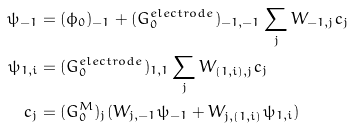<formula> <loc_0><loc_0><loc_500><loc_500>\psi _ { - 1 } & = ( \phi _ { 0 } ) _ { - 1 } + ( G _ { 0 } ^ { e l e c t r o d e } ) _ { - 1 , - 1 } \sum _ { j } W _ { - 1 , j } c _ { j } \\ \psi _ { 1 , i } & = ( G _ { 0 } ^ { e l e c t r o d e } ) _ { 1 , 1 } \sum _ { j } W _ { ( 1 , i ) , j } c _ { j } \\ c _ { j } & = ( G _ { 0 } ^ { M } ) _ { j } ( W _ { j , - 1 } \psi _ { - 1 } + W _ { j , ( 1 , i ) } \psi _ { 1 , i } )</formula> 